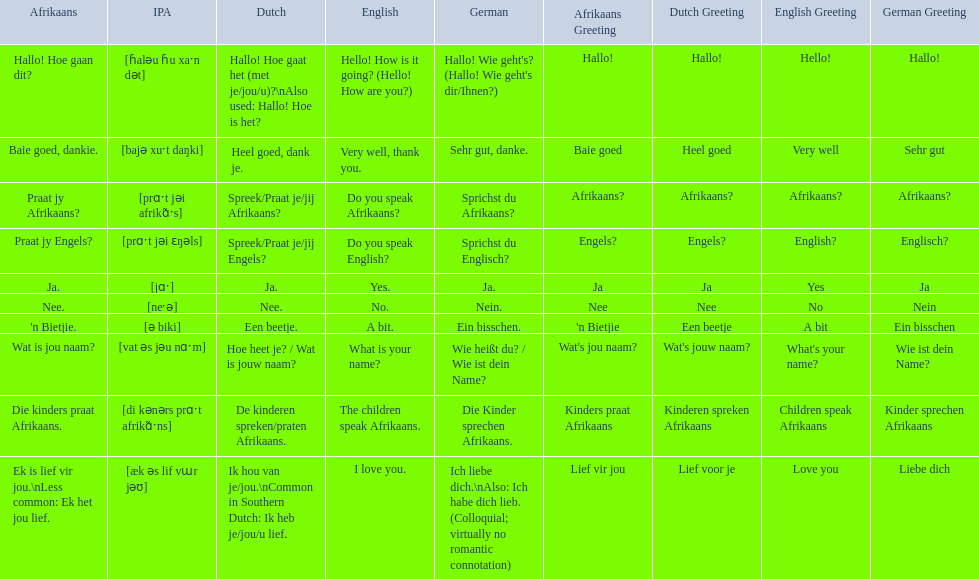Which phrases are said in africaans? Hallo! Hoe gaan dit?, Baie goed, dankie., Praat jy Afrikaans?, Praat jy Engels?, Ja., Nee., 'n Bietjie., Wat is jou naam?, Die kinders praat Afrikaans., Ek is lief vir jou.\nLess common: Ek het jou lief. Which of these mean how do you speak afrikaans? Praat jy Afrikaans?. 